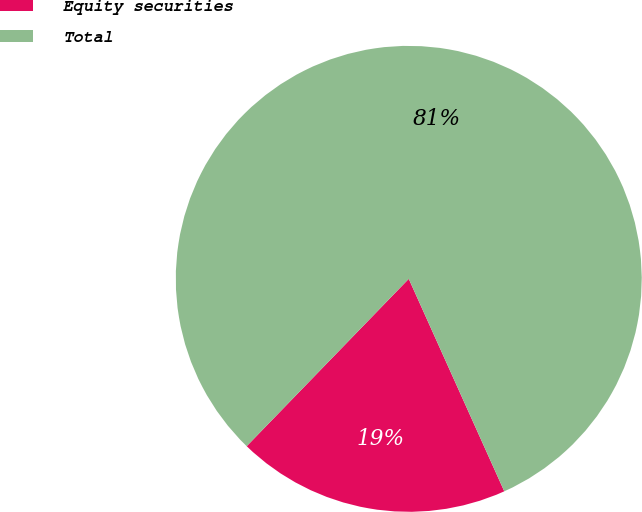<chart> <loc_0><loc_0><loc_500><loc_500><pie_chart><fcel>Equity securities<fcel>Total<nl><fcel>18.97%<fcel>81.03%<nl></chart> 